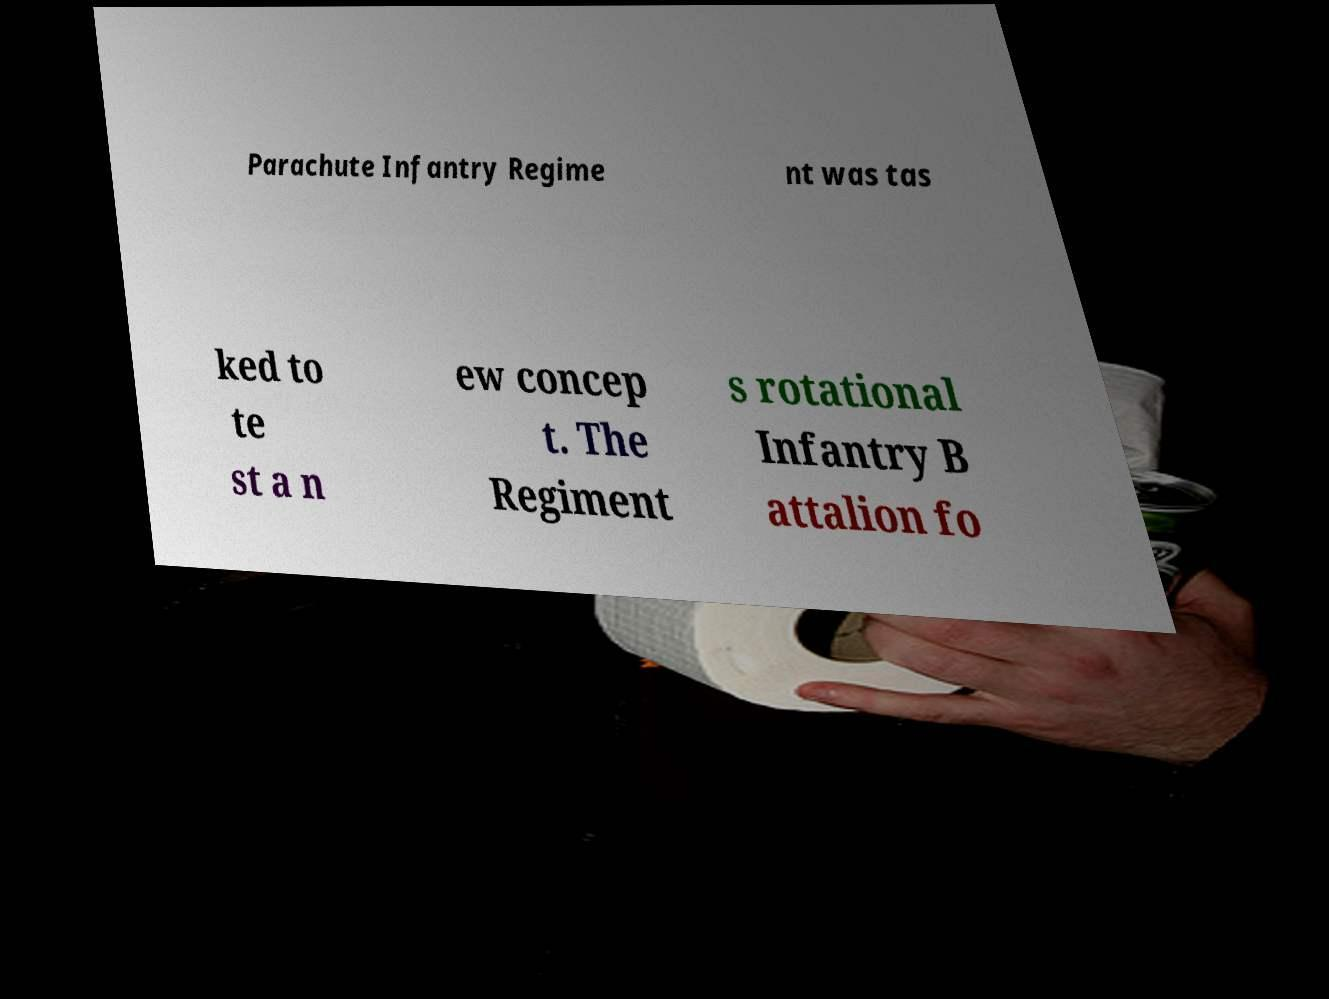Can you read and provide the text displayed in the image?This photo seems to have some interesting text. Can you extract and type it out for me? Parachute Infantry Regime nt was tas ked to te st a n ew concep t. The Regiment s rotational Infantry B attalion fo 